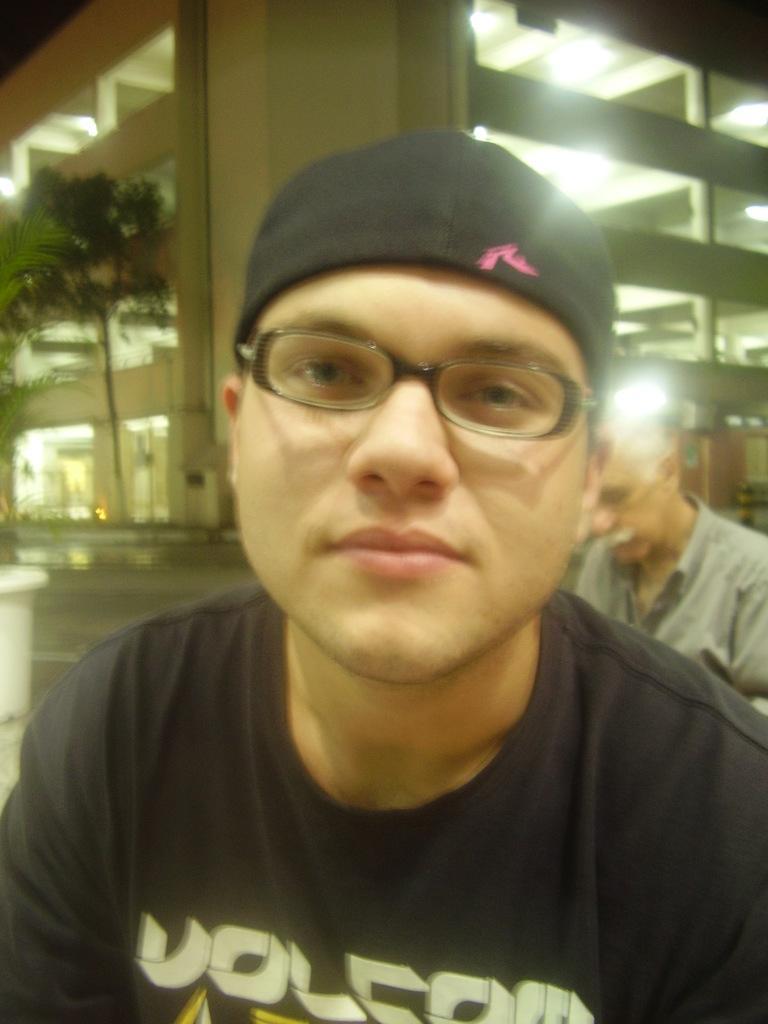How would you summarize this image in a sentence or two? In this picture, we can see a few people, ground, plant in a pot, tree, building with windows, pillars and lights. 